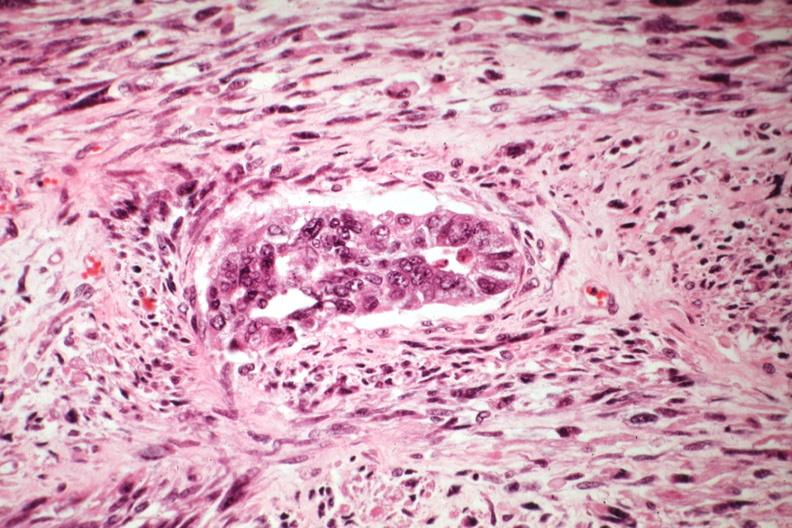what does this image show?
Answer the question using a single word or phrase. Malignant gland and stoma 